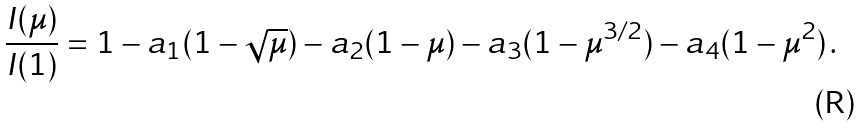<formula> <loc_0><loc_0><loc_500><loc_500>\frac { I ( \mu ) } { I ( 1 ) } = 1 - a _ { 1 } ( 1 - \sqrt { \mu } ) - a _ { 2 } ( 1 - \mu ) - a _ { 3 } ( 1 - \mu ^ { 3 / 2 } ) - a _ { 4 } ( 1 - \mu ^ { 2 } ) \, .</formula> 